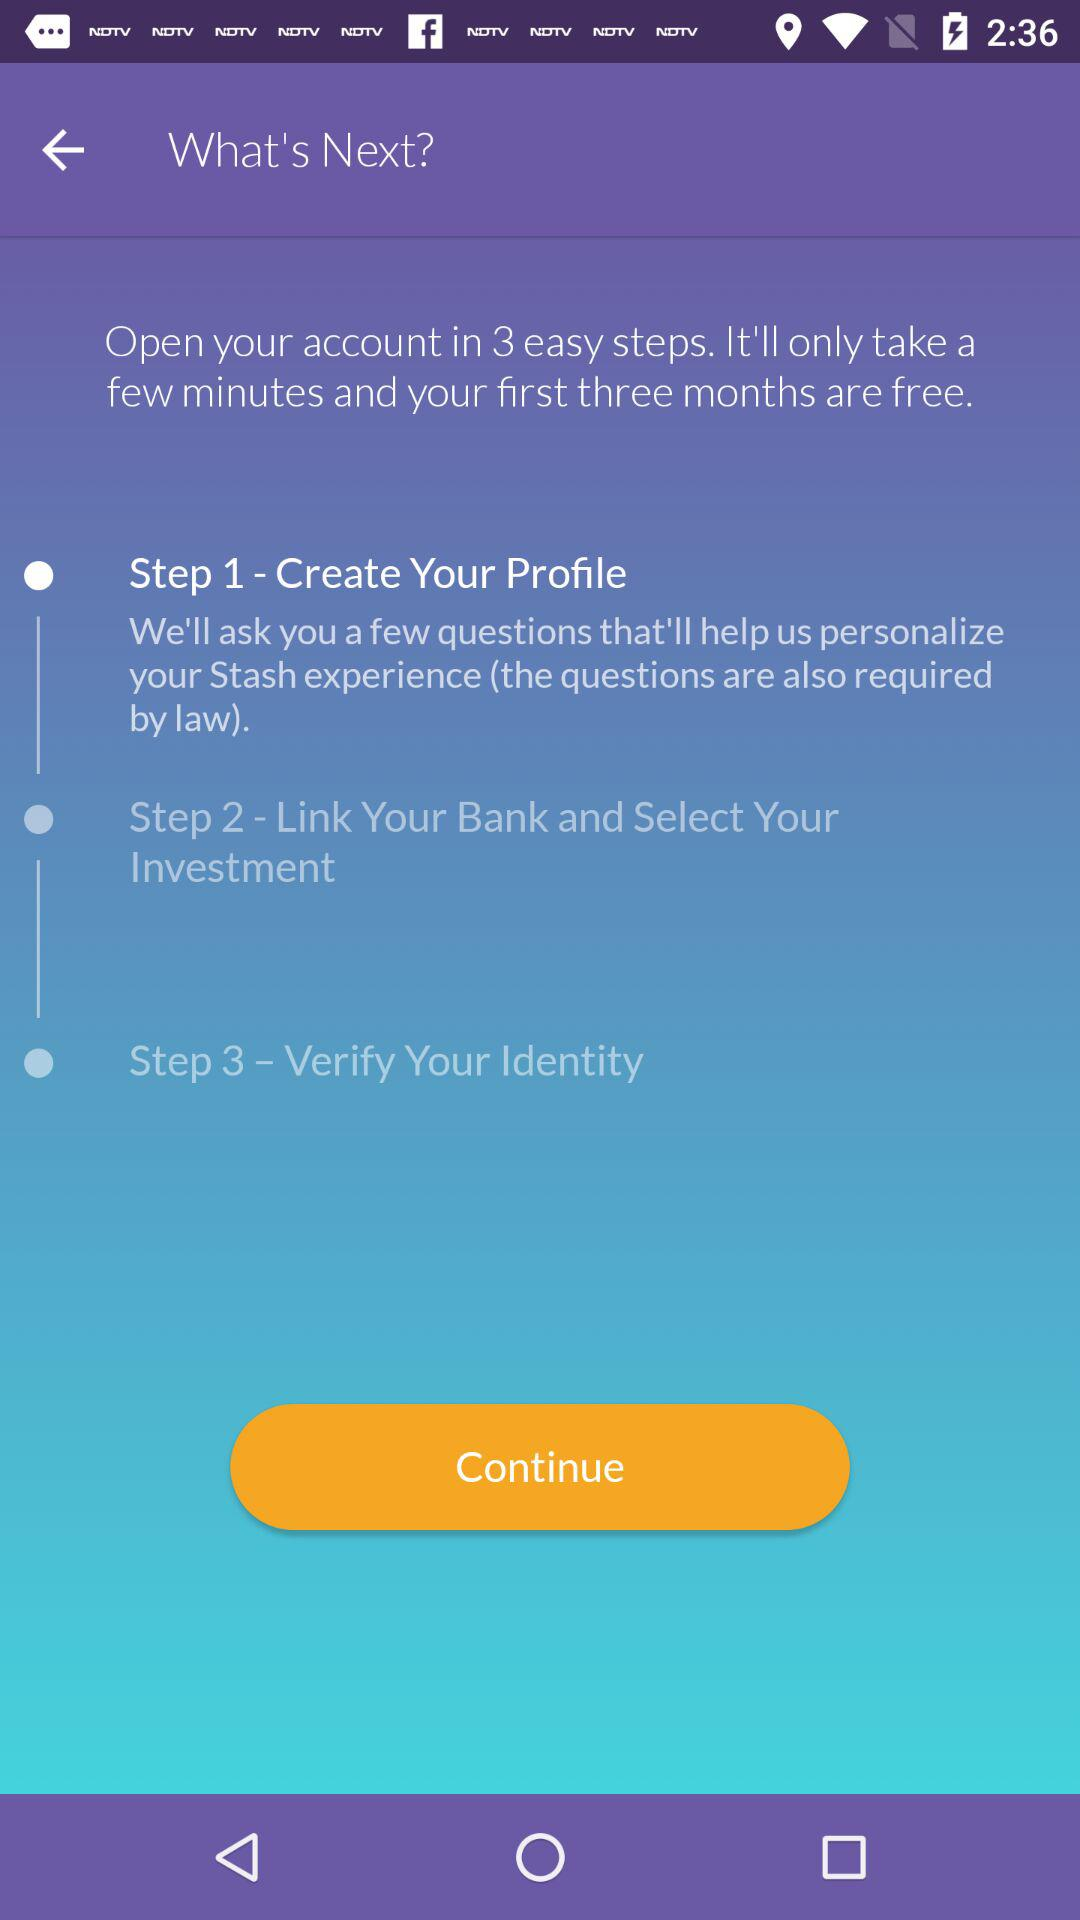What should we do in the third step? You should verify your identity in the third step. 